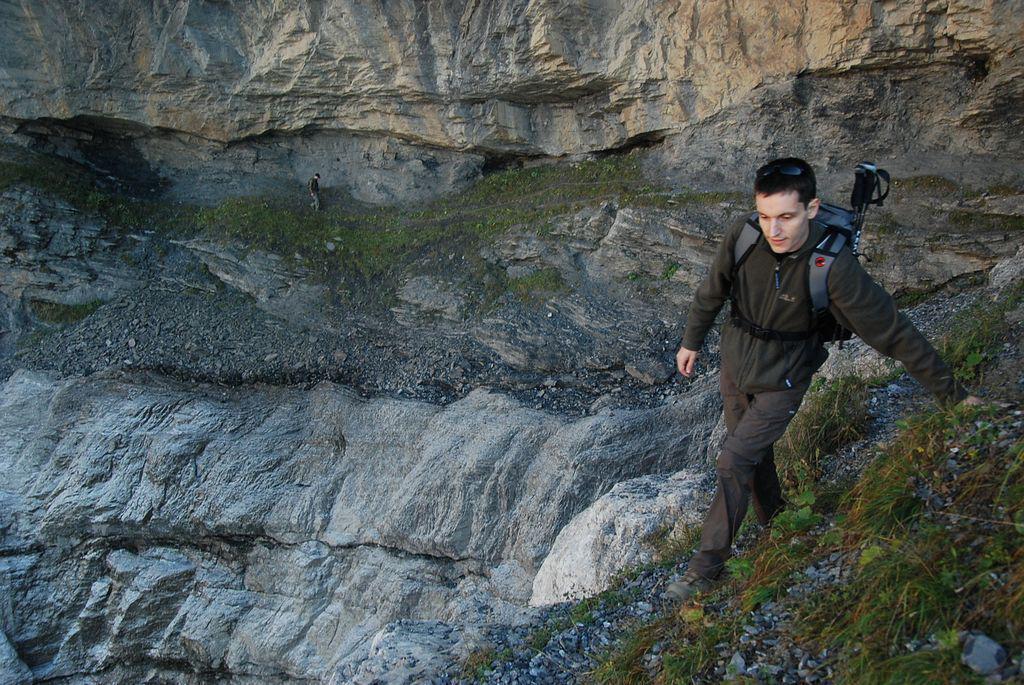In one or two sentences, can you explain what this image depicts? In this image in the center there is a man walking. On the right side there are grass on the ground and in the background there is a person and there's grass on the ground. 